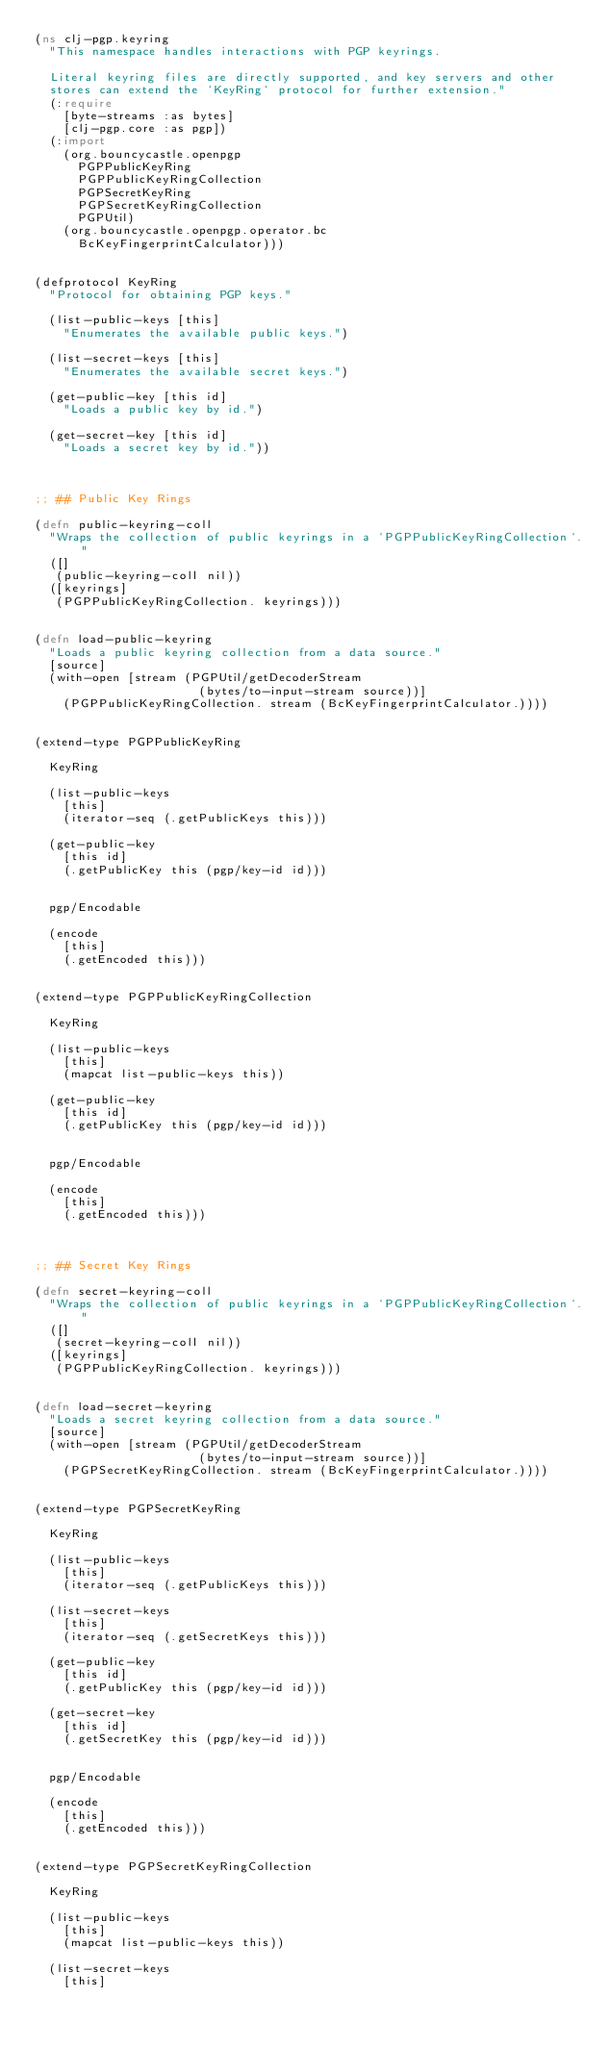Convert code to text. <code><loc_0><loc_0><loc_500><loc_500><_Clojure_>(ns clj-pgp.keyring
  "This namespace handles interactions with PGP keyrings.

  Literal keyring files are directly supported, and key servers and other
  stores can extend the `KeyRing` protocol for further extension."
  (:require
    [byte-streams :as bytes]
    [clj-pgp.core :as pgp])
  (:import
    (org.bouncycastle.openpgp
      PGPPublicKeyRing
      PGPPublicKeyRingCollection
      PGPSecretKeyRing
      PGPSecretKeyRingCollection
      PGPUtil)
    (org.bouncycastle.openpgp.operator.bc
      BcKeyFingerprintCalculator)))


(defprotocol KeyRing
  "Protocol for obtaining PGP keys."

  (list-public-keys [this]
    "Enumerates the available public keys.")

  (list-secret-keys [this]
    "Enumerates the available secret keys.")

  (get-public-key [this id]
    "Loads a public key by id.")

  (get-secret-key [this id]
    "Loads a secret key by id."))



;; ## Public Key Rings

(defn public-keyring-coll
  "Wraps the collection of public keyrings in a `PGPPublicKeyRingCollection`."
  ([]
   (public-keyring-coll nil))
  ([keyrings]
   (PGPPublicKeyRingCollection. keyrings)))


(defn load-public-keyring
  "Loads a public keyring collection from a data source."
  [source]
  (with-open [stream (PGPUtil/getDecoderStream
                       (bytes/to-input-stream source))]
    (PGPPublicKeyRingCollection. stream (BcKeyFingerprintCalculator.))))


(extend-type PGPPublicKeyRing

  KeyRing

  (list-public-keys
    [this]
    (iterator-seq (.getPublicKeys this)))

  (get-public-key
    [this id]
    (.getPublicKey this (pgp/key-id id)))


  pgp/Encodable

  (encode
    [this]
    (.getEncoded this)))


(extend-type PGPPublicKeyRingCollection

  KeyRing

  (list-public-keys
    [this]
    (mapcat list-public-keys this))

  (get-public-key
    [this id]
    (.getPublicKey this (pgp/key-id id)))


  pgp/Encodable

  (encode
    [this]
    (.getEncoded this)))



;; ## Secret Key Rings

(defn secret-keyring-coll
  "Wraps the collection of public keyrings in a `PGPPublicKeyRingCollection`."
  ([]
   (secret-keyring-coll nil))
  ([keyrings]
   (PGPPublicKeyRingCollection. keyrings)))


(defn load-secret-keyring
  "Loads a secret keyring collection from a data source."
  [source]
  (with-open [stream (PGPUtil/getDecoderStream
                       (bytes/to-input-stream source))]
    (PGPSecretKeyRingCollection. stream (BcKeyFingerprintCalculator.))))


(extend-type PGPSecretKeyRing

  KeyRing

  (list-public-keys
    [this]
    (iterator-seq (.getPublicKeys this)))

  (list-secret-keys
    [this]
    (iterator-seq (.getSecretKeys this)))

  (get-public-key
    [this id]
    (.getPublicKey this (pgp/key-id id)))

  (get-secret-key
    [this id]
    (.getSecretKey this (pgp/key-id id)))


  pgp/Encodable

  (encode
    [this]
    (.getEncoded this)))


(extend-type PGPSecretKeyRingCollection

  KeyRing

  (list-public-keys
    [this]
    (mapcat list-public-keys this))

  (list-secret-keys
    [this]</code> 